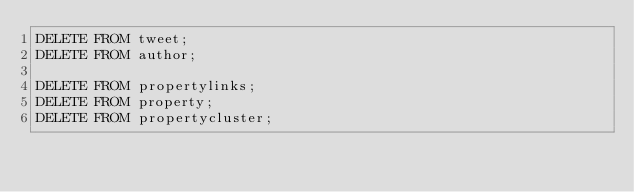<code> <loc_0><loc_0><loc_500><loc_500><_SQL_>DELETE FROM tweet;
DELETE FROM author;

DELETE FROM propertylinks;
DELETE FROM property;
DELETE FROM propertycluster;


</code> 